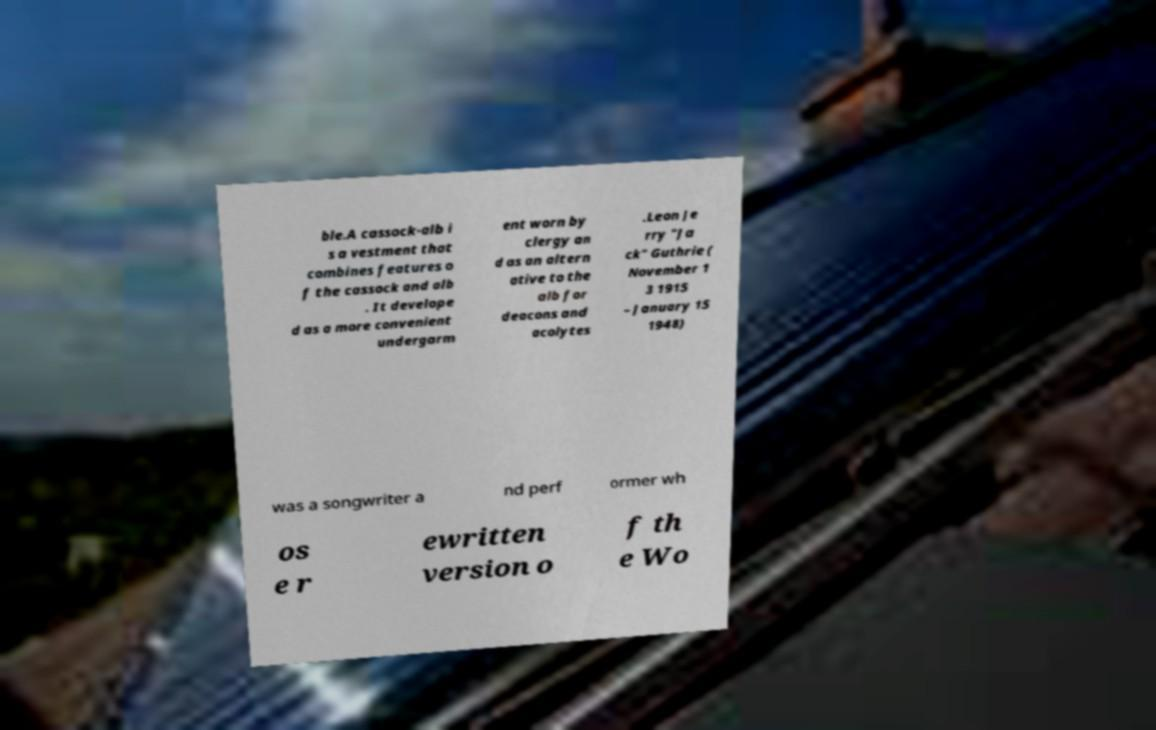I need the written content from this picture converted into text. Can you do that? ble.A cassock-alb i s a vestment that combines features o f the cassock and alb . It develope d as a more convenient undergarm ent worn by clergy an d as an altern ative to the alb for deacons and acolytes .Leon Je rry "Ja ck" Guthrie ( November 1 3 1915 – January 15 1948) was a songwriter a nd perf ormer wh os e r ewritten version o f th e Wo 